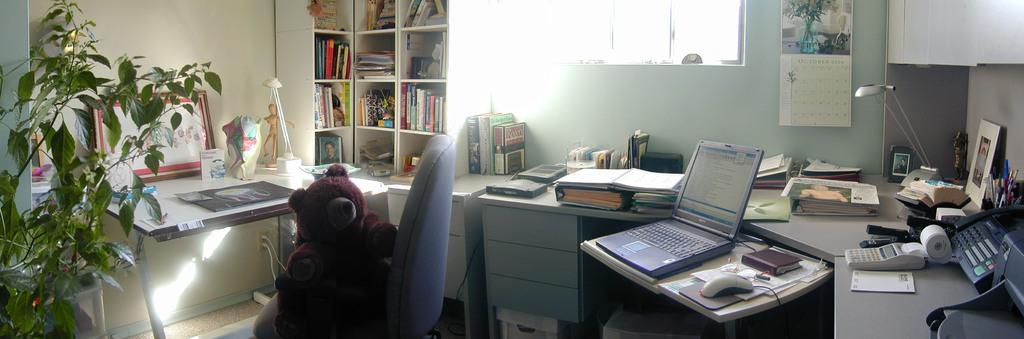Can you describe this image briefly? In this image I see a plant, a toy on this chair and there are tables on which there are many things and I can see a rack which are full of books and a window. 